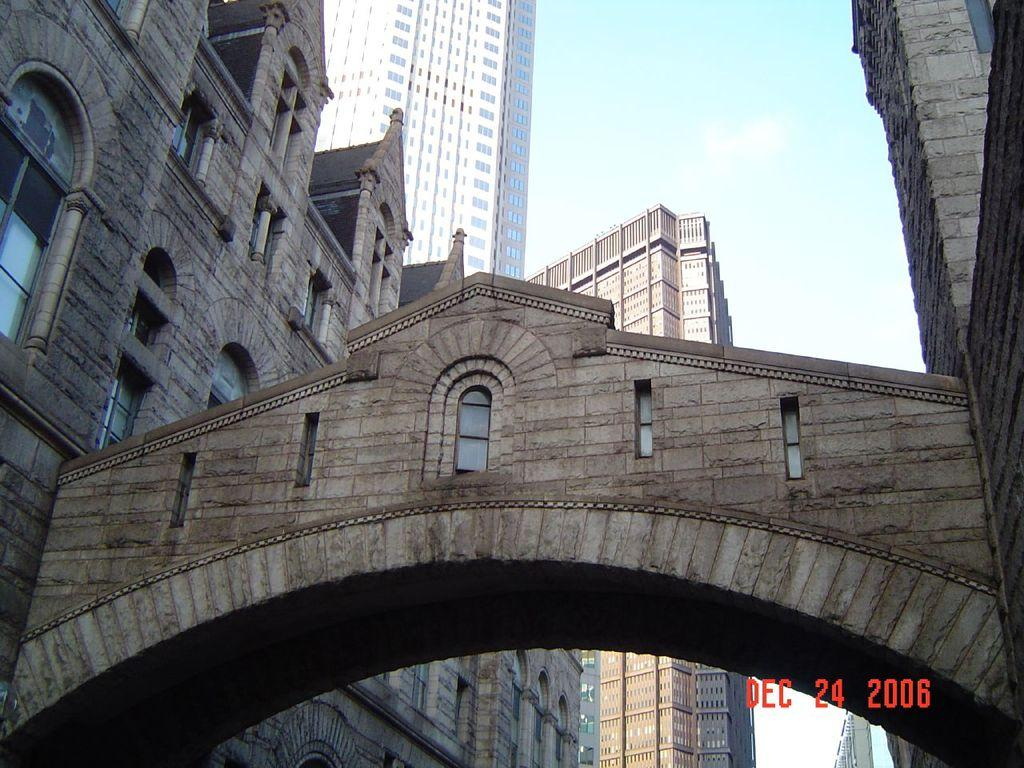What type of structures are depicted in the image? There are buildings with windows in the image. What architectural feature can be seen on the buildings? The buildings have an arch. What can be seen in the background of the image? The sky is visible in the background of the image. What is present in the sky? Clouds are present in the sky. How many men are standing next to the beggar in the image? There is no mention of men or a beggar in the image; it features buildings with windows, an arch, and a sky with clouds. 